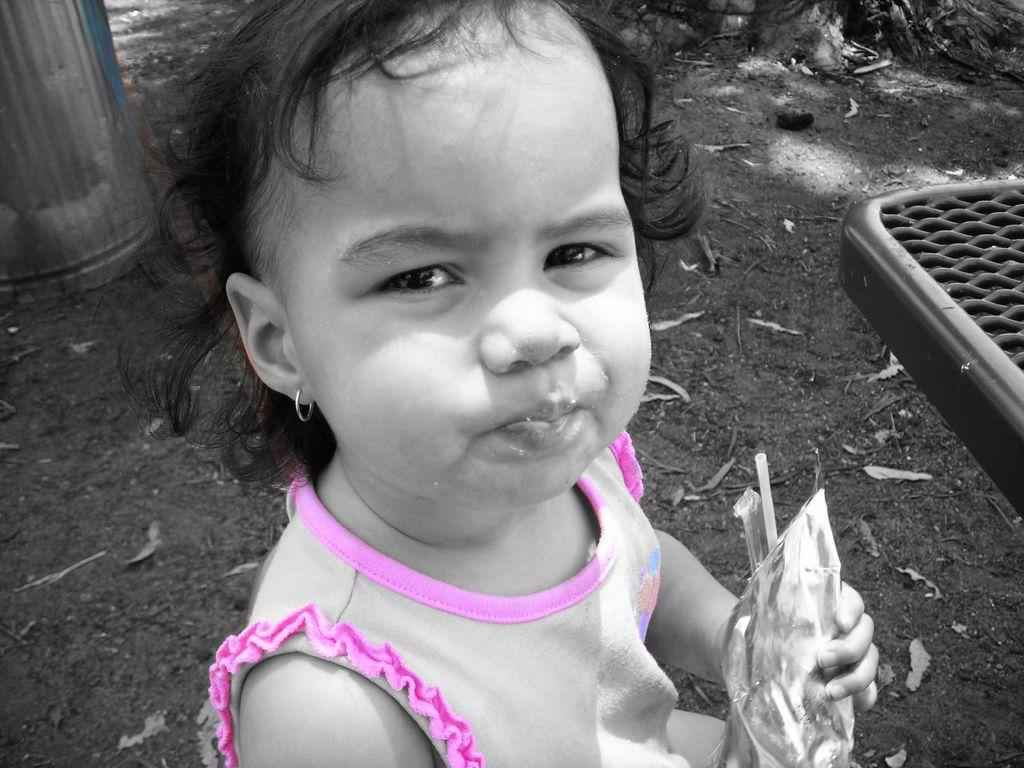Could you give a brief overview of what you see in this image? In this image I can see a person is wearing pink and white color dress and holding some object. Background I can see few trees. 